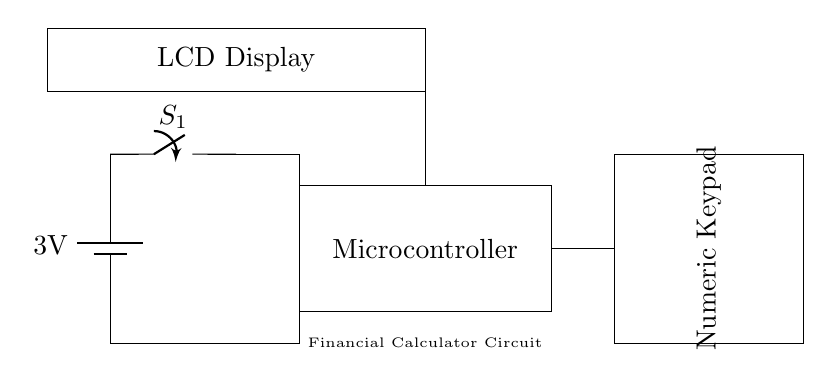what is the voltage provided by the battery? The circuit diagram shows a battery with a label indicating a voltage of 3 volts. This is the potential difference that powers the circuit.
Answer: 3 volts which component is used to control power flow? The circuit includes a switch labeled S1, which is essential for managing the on/off status of the circuit. When closed, it allows current to flow; when open, it cuts off the power.
Answer: switch how many main functional components are there in the circuit? The circuit comprises three main functional components: a microcontroller, a numeric keypad, and an LCD display. These components serve distinct roles in performing financial calculations and displaying results.
Answer: three what is the role of the microcontroller in this circuit? The microcontroller, represented as a rectangle in the circuit, is responsible for processing input from the numeric keypad and controlling the output displayed on the LCD. It functions as the brain of the calculator.
Answer: processing calculations what would happen if the battery voltage is too low? If the battery voltage drops below the required threshold, the circuit may not function properly. The microcontroller might not operate efficiently, leading to incorrect calculations or a complete failure to power on.
Answer: malfunction where does the output information appear in this circuit? The output of the calculations is displayed on the LCD screen, which is positioned at a higher level in the circuit diagram, indicating it as the visual output interface for the user.
Answer: LCD display 